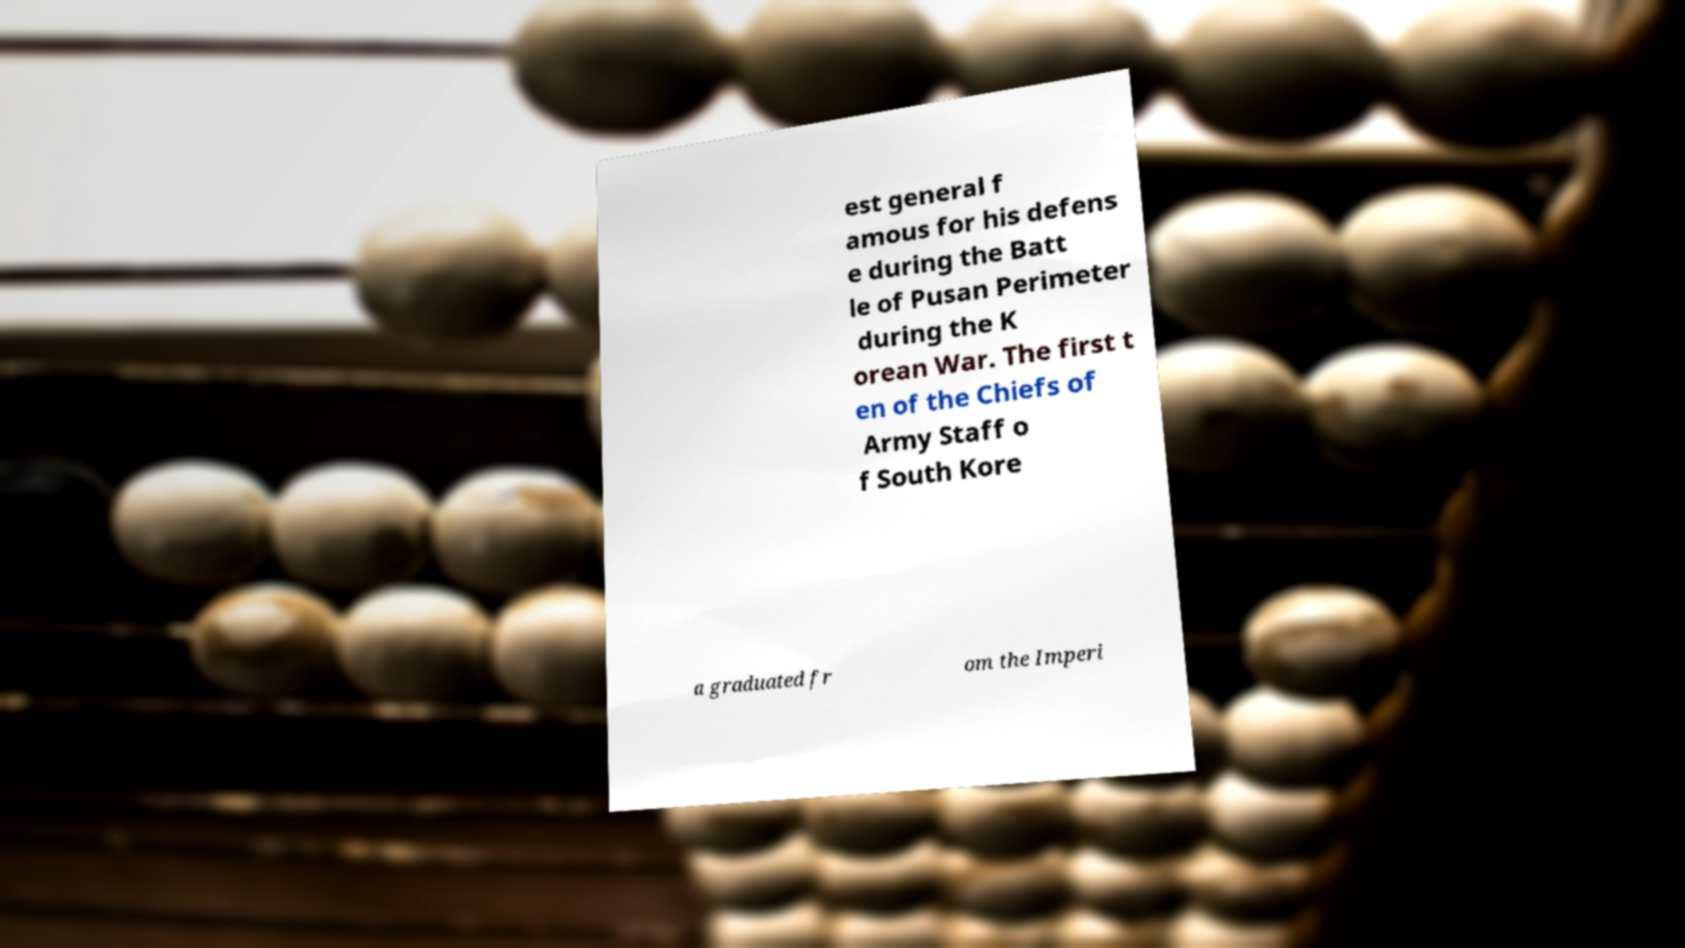Please identify and transcribe the text found in this image. est general f amous for his defens e during the Batt le of Pusan Perimeter during the K orean War. The first t en of the Chiefs of Army Staff o f South Kore a graduated fr om the Imperi 